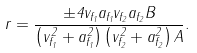Convert formula to latex. <formula><loc_0><loc_0><loc_500><loc_500>r = { \frac { \pm 4 v _ { f _ { 1 } } a _ { f _ { 1 } } v _ { f _ { 2 } } a _ { f _ { 2 } } B } { \left ( v _ { f _ { 1 } } ^ { 2 } + a _ { f _ { 1 } } ^ { 2 } \right ) \left ( v _ { f _ { 2 } } ^ { 2 } + a _ { f _ { 2 } } ^ { 2 } \right ) A } } .</formula> 